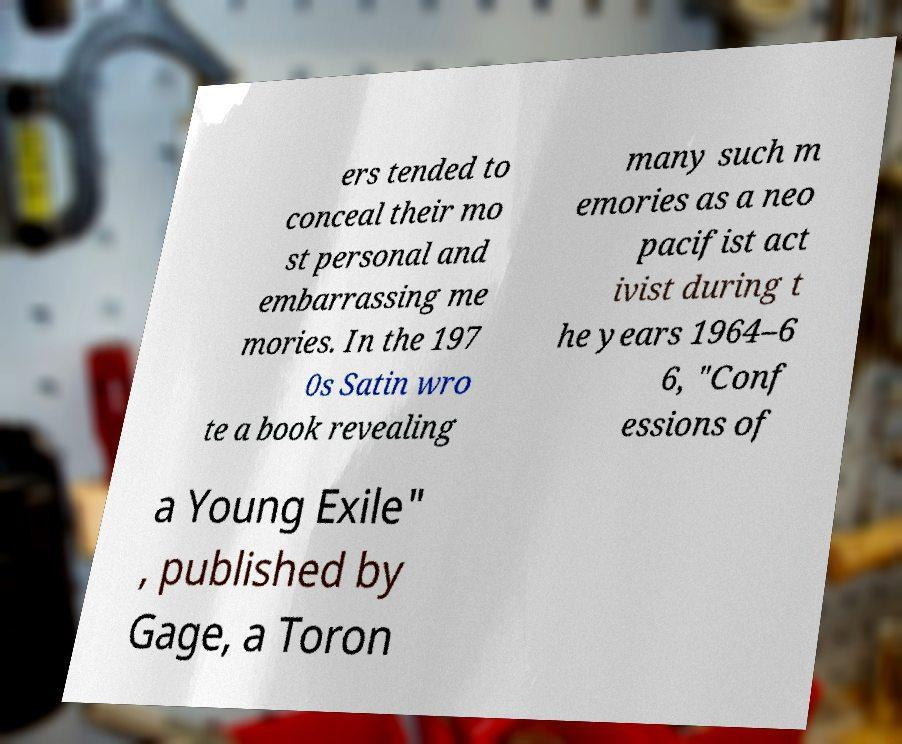There's text embedded in this image that I need extracted. Can you transcribe it verbatim? ers tended to conceal their mo st personal and embarrassing me mories. In the 197 0s Satin wro te a book revealing many such m emories as a neo pacifist act ivist during t he years 1964–6 6, "Conf essions of a Young Exile" , published by Gage, a Toron 